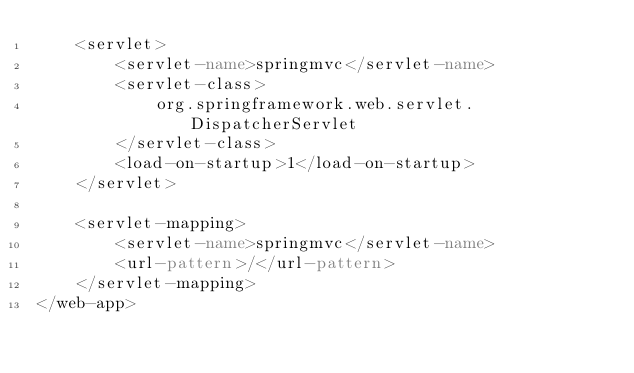<code> <loc_0><loc_0><loc_500><loc_500><_XML_>    <servlet>
        <servlet-name>springmvc</servlet-name>
        <servlet-class>
            org.springframework.web.servlet.DispatcherServlet
        </servlet-class>
        <load-on-startup>1</load-on-startup>
    </servlet>

    <servlet-mapping>
        <servlet-name>springmvc</servlet-name>
        <url-pattern>/</url-pattern>
    </servlet-mapping>
</web-app>

</code> 